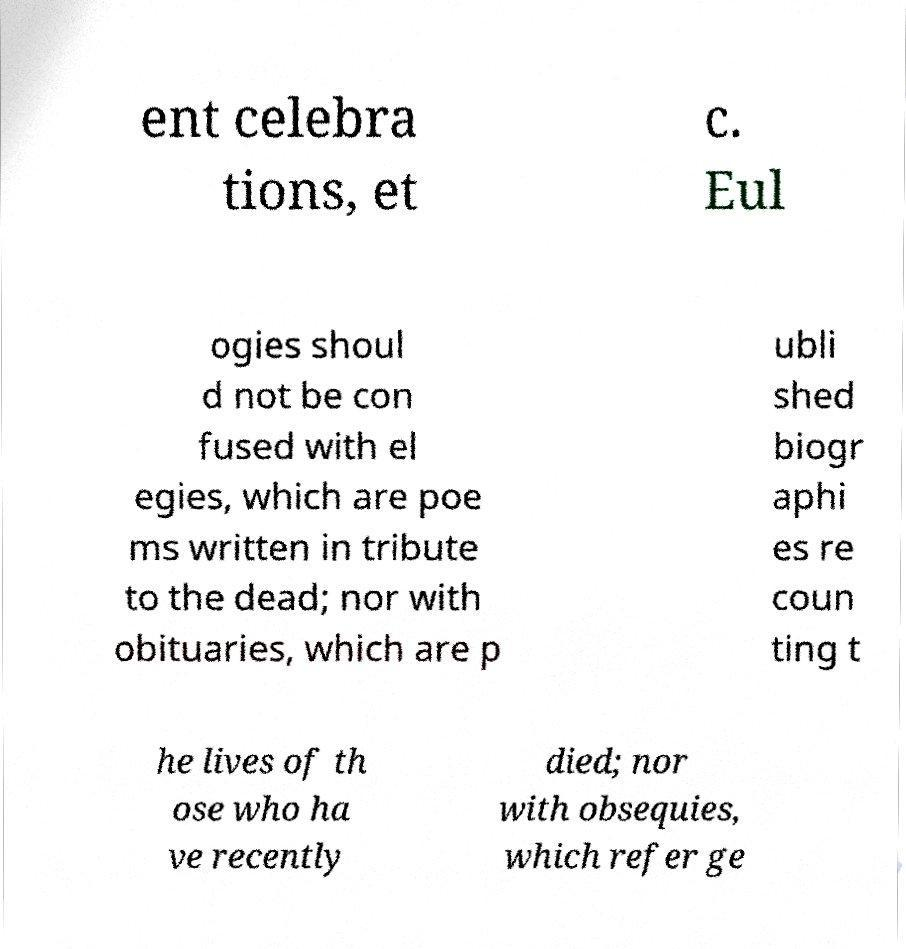I need the written content from this picture converted into text. Can you do that? ent celebra tions, et c. Eul ogies shoul d not be con fused with el egies, which are poe ms written in tribute to the dead; nor with obituaries, which are p ubli shed biogr aphi es re coun ting t he lives of th ose who ha ve recently died; nor with obsequies, which refer ge 